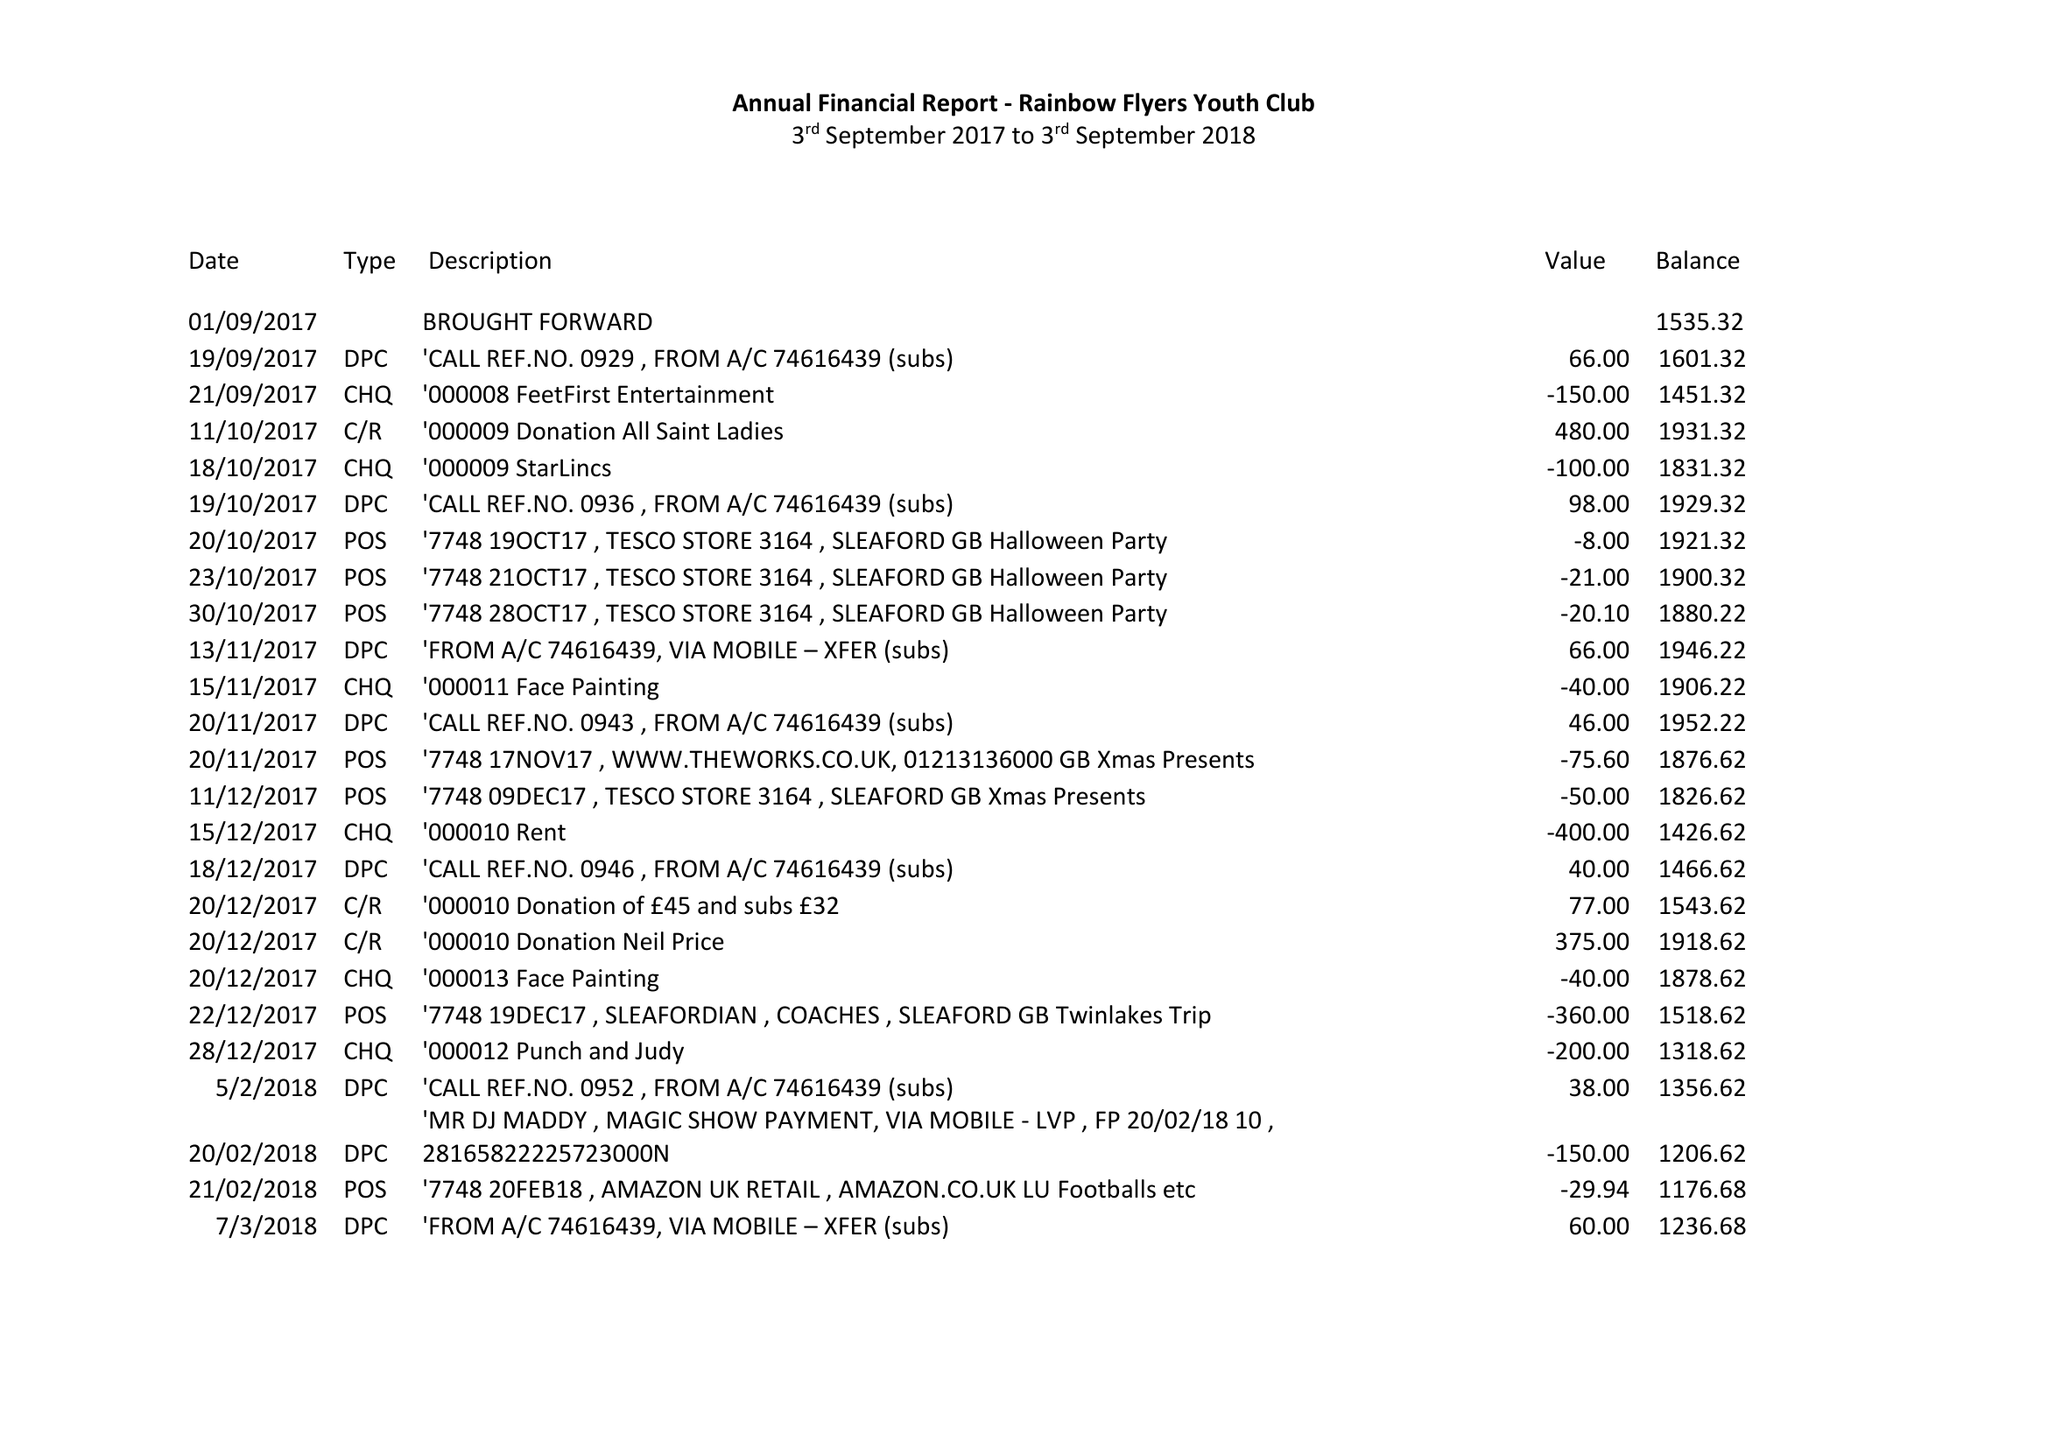What is the value for the address__post_town?
Answer the question using a single word or phrase. SLEAFORD 